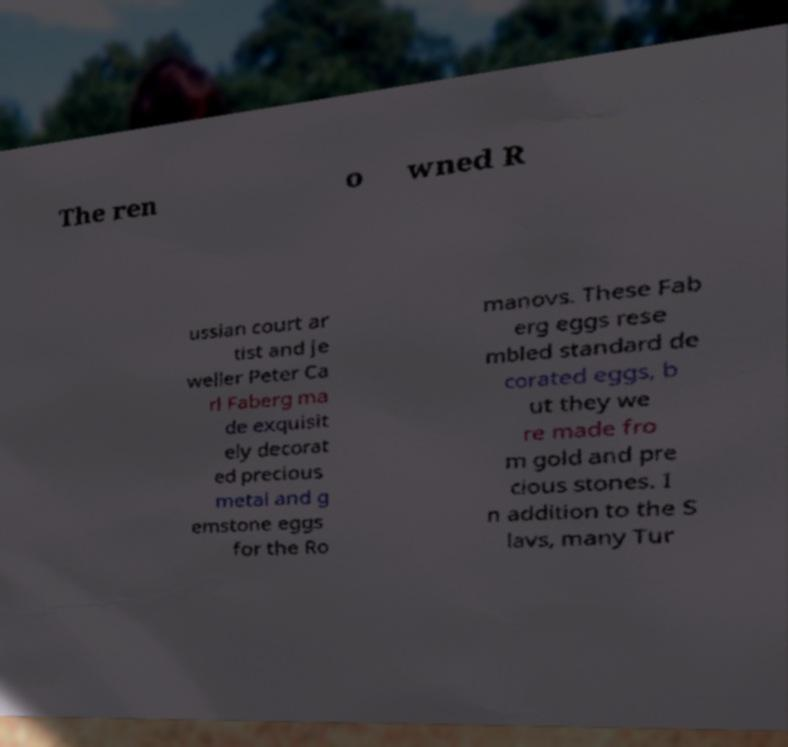Can you read and provide the text displayed in the image?This photo seems to have some interesting text. Can you extract and type it out for me? The ren o wned R ussian court ar tist and je weller Peter Ca rl Faberg ma de exquisit ely decorat ed precious metal and g emstone eggs for the Ro manovs. These Fab erg eggs rese mbled standard de corated eggs, b ut they we re made fro m gold and pre cious stones. I n addition to the S lavs, many Tur 